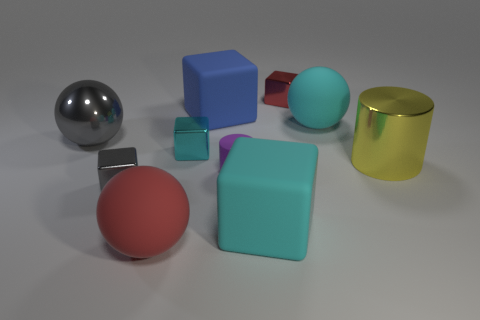Subtract 1 balls. How many balls are left? 2 Subtract all cyan cubes. How many cubes are left? 3 Subtract all small red cubes. How many cubes are left? 4 Subtract all gray cubes. Subtract all green balls. How many cubes are left? 4 Subtract all cylinders. How many objects are left? 8 Add 4 tiny red cubes. How many tiny red cubes exist? 5 Subtract 1 blue blocks. How many objects are left? 9 Subtract all big cyan metal things. Subtract all cyan metal objects. How many objects are left? 9 Add 8 small matte objects. How many small matte objects are left? 9 